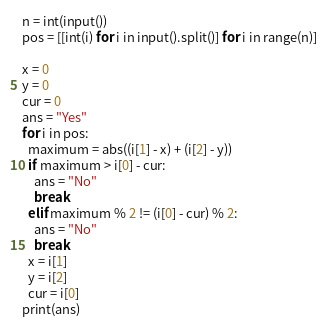Convert code to text. <code><loc_0><loc_0><loc_500><loc_500><_Python_>n = int(input())
pos = [[int(i) for i in input().split()] for i in range(n)] 

x = 0
y = 0
cur = 0
ans = "Yes"
for i in pos:
  maximum = abs((i[1] - x) + (i[2] - y))
  if maximum > i[0] - cur:
    ans = "No"
    break
  elif maximum % 2 != (i[0] - cur) % 2:
    ans = "No"
    break
  x = i[1]
  y = i[2]
  cur = i[0]
print(ans)</code> 